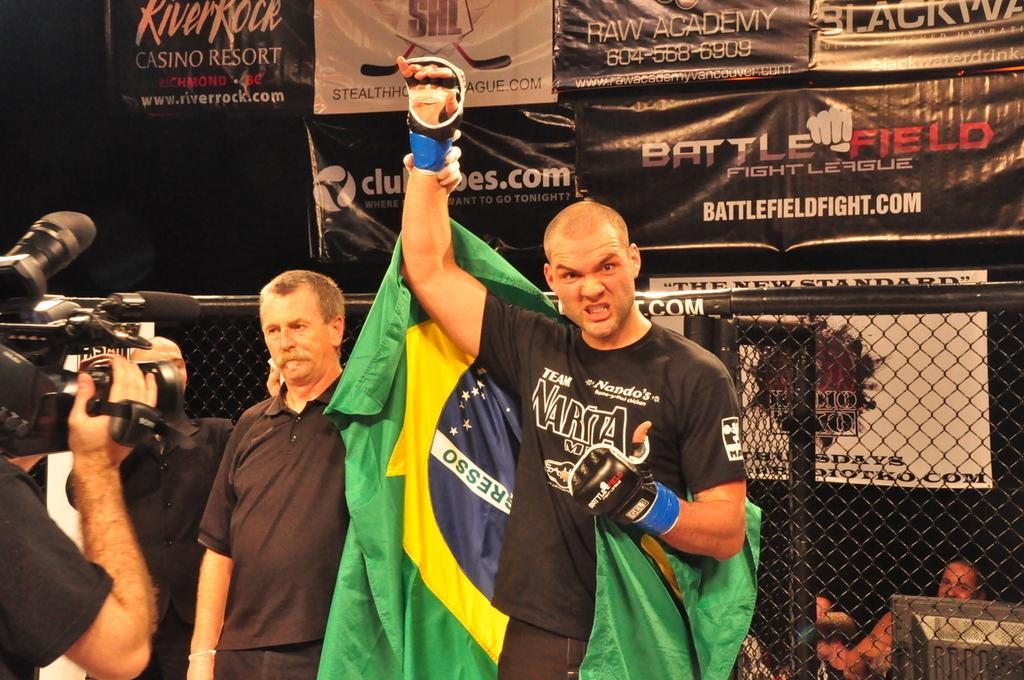<image>
Present a compact description of the photo's key features. Behind a fighter is a banner that shows battlefieldfight.com 